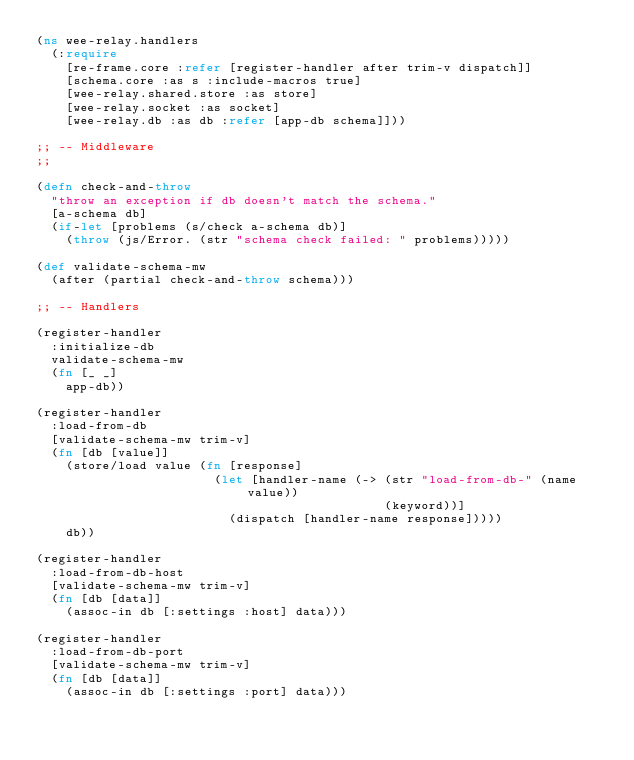<code> <loc_0><loc_0><loc_500><loc_500><_Clojure_>(ns wee-relay.handlers
  (:require
    [re-frame.core :refer [register-handler after trim-v dispatch]]
    [schema.core :as s :include-macros true]
    [wee-relay.shared.store :as store]
    [wee-relay.socket :as socket]
    [wee-relay.db :as db :refer [app-db schema]]))

;; -- Middleware
;;

(defn check-and-throw
  "throw an exception if db doesn't match the schema."
  [a-schema db]
  (if-let [problems (s/check a-schema db)]
    (throw (js/Error. (str "schema check failed: " problems)))))

(def validate-schema-mw
  (after (partial check-and-throw schema)))

;; -- Handlers

(register-handler
  :initialize-db
  validate-schema-mw
  (fn [_ _]
    app-db))

(register-handler
  :load-from-db
  [validate-schema-mw trim-v]
  (fn [db [value]]
    (store/load value (fn [response]
                        (let [handler-name (-> (str "load-from-db-" (name value))
                                               (keyword))]
                          (dispatch [handler-name response]))))
    db))

(register-handler
  :load-from-db-host
  [validate-schema-mw trim-v]
  (fn [db [data]]
    (assoc-in db [:settings :host] data)))

(register-handler
  :load-from-db-port
  [validate-schema-mw trim-v]
  (fn [db [data]]
    (assoc-in db [:settings :port] data)))
</code> 